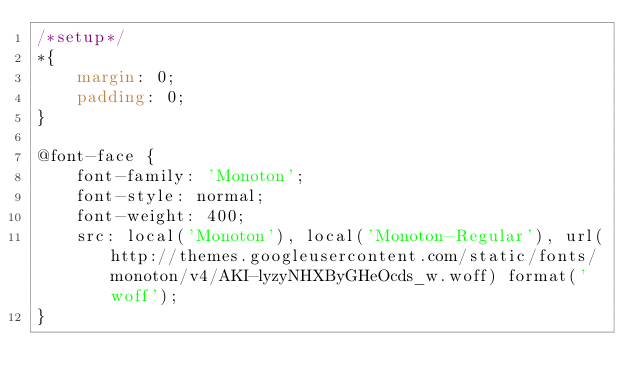<code> <loc_0><loc_0><loc_500><loc_500><_CSS_>/*setup*/
*{
    margin: 0;
    padding: 0;
}

@font-face {
    font-family: 'Monoton';
    font-style: normal;
    font-weight: 400;
    src: local('Monoton'), local('Monoton-Regular'), url(http://themes.googleusercontent.com/static/fonts/monoton/v4/AKI-lyzyNHXByGHeOcds_w.woff) format('woff');
}
</code> 